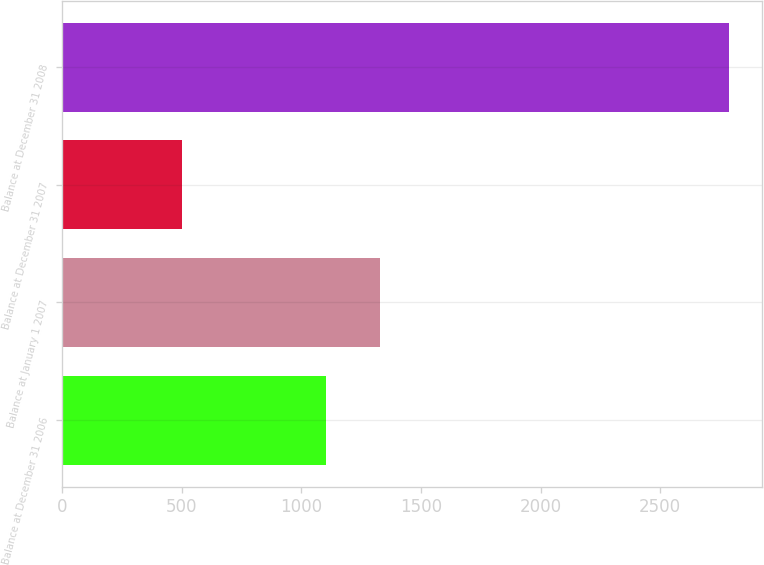<chart> <loc_0><loc_0><loc_500><loc_500><bar_chart><fcel>Balance at December 31 2006<fcel>Balance at January 1 2007<fcel>Balance at December 31 2007<fcel>Balance at December 31 2008<nl><fcel>1102<fcel>1330.3<fcel>503<fcel>2786<nl></chart> 